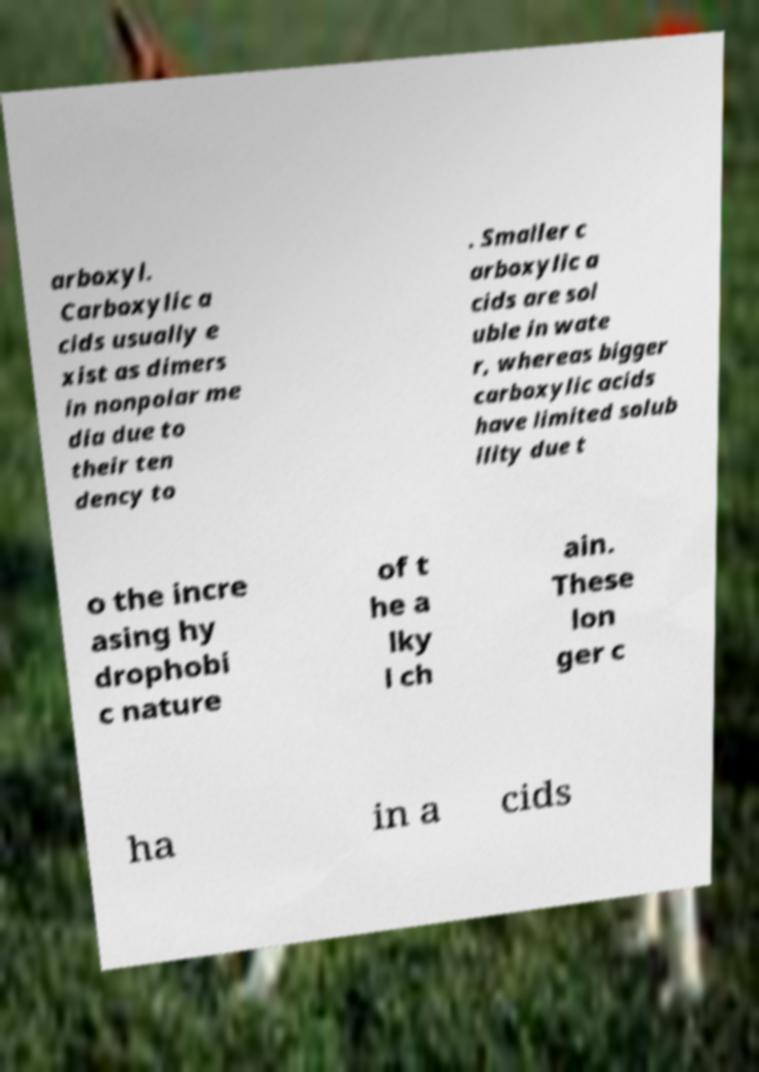Can you accurately transcribe the text from the provided image for me? arboxyl. Carboxylic a cids usually e xist as dimers in nonpolar me dia due to their ten dency to . Smaller c arboxylic a cids are sol uble in wate r, whereas bigger carboxylic acids have limited solub ility due t o the incre asing hy drophobi c nature of t he a lky l ch ain. These lon ger c ha in a cids 